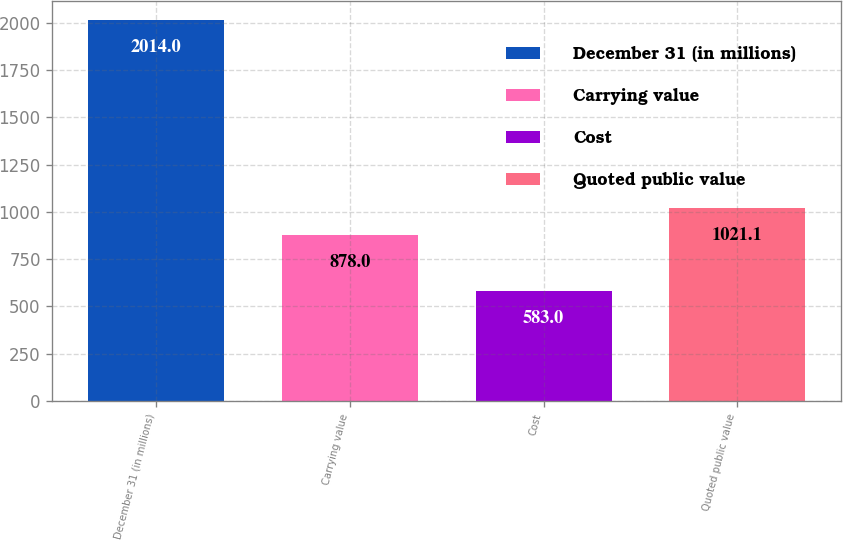Convert chart to OTSL. <chart><loc_0><loc_0><loc_500><loc_500><bar_chart><fcel>December 31 (in millions)<fcel>Carrying value<fcel>Cost<fcel>Quoted public value<nl><fcel>2014<fcel>878<fcel>583<fcel>1021.1<nl></chart> 